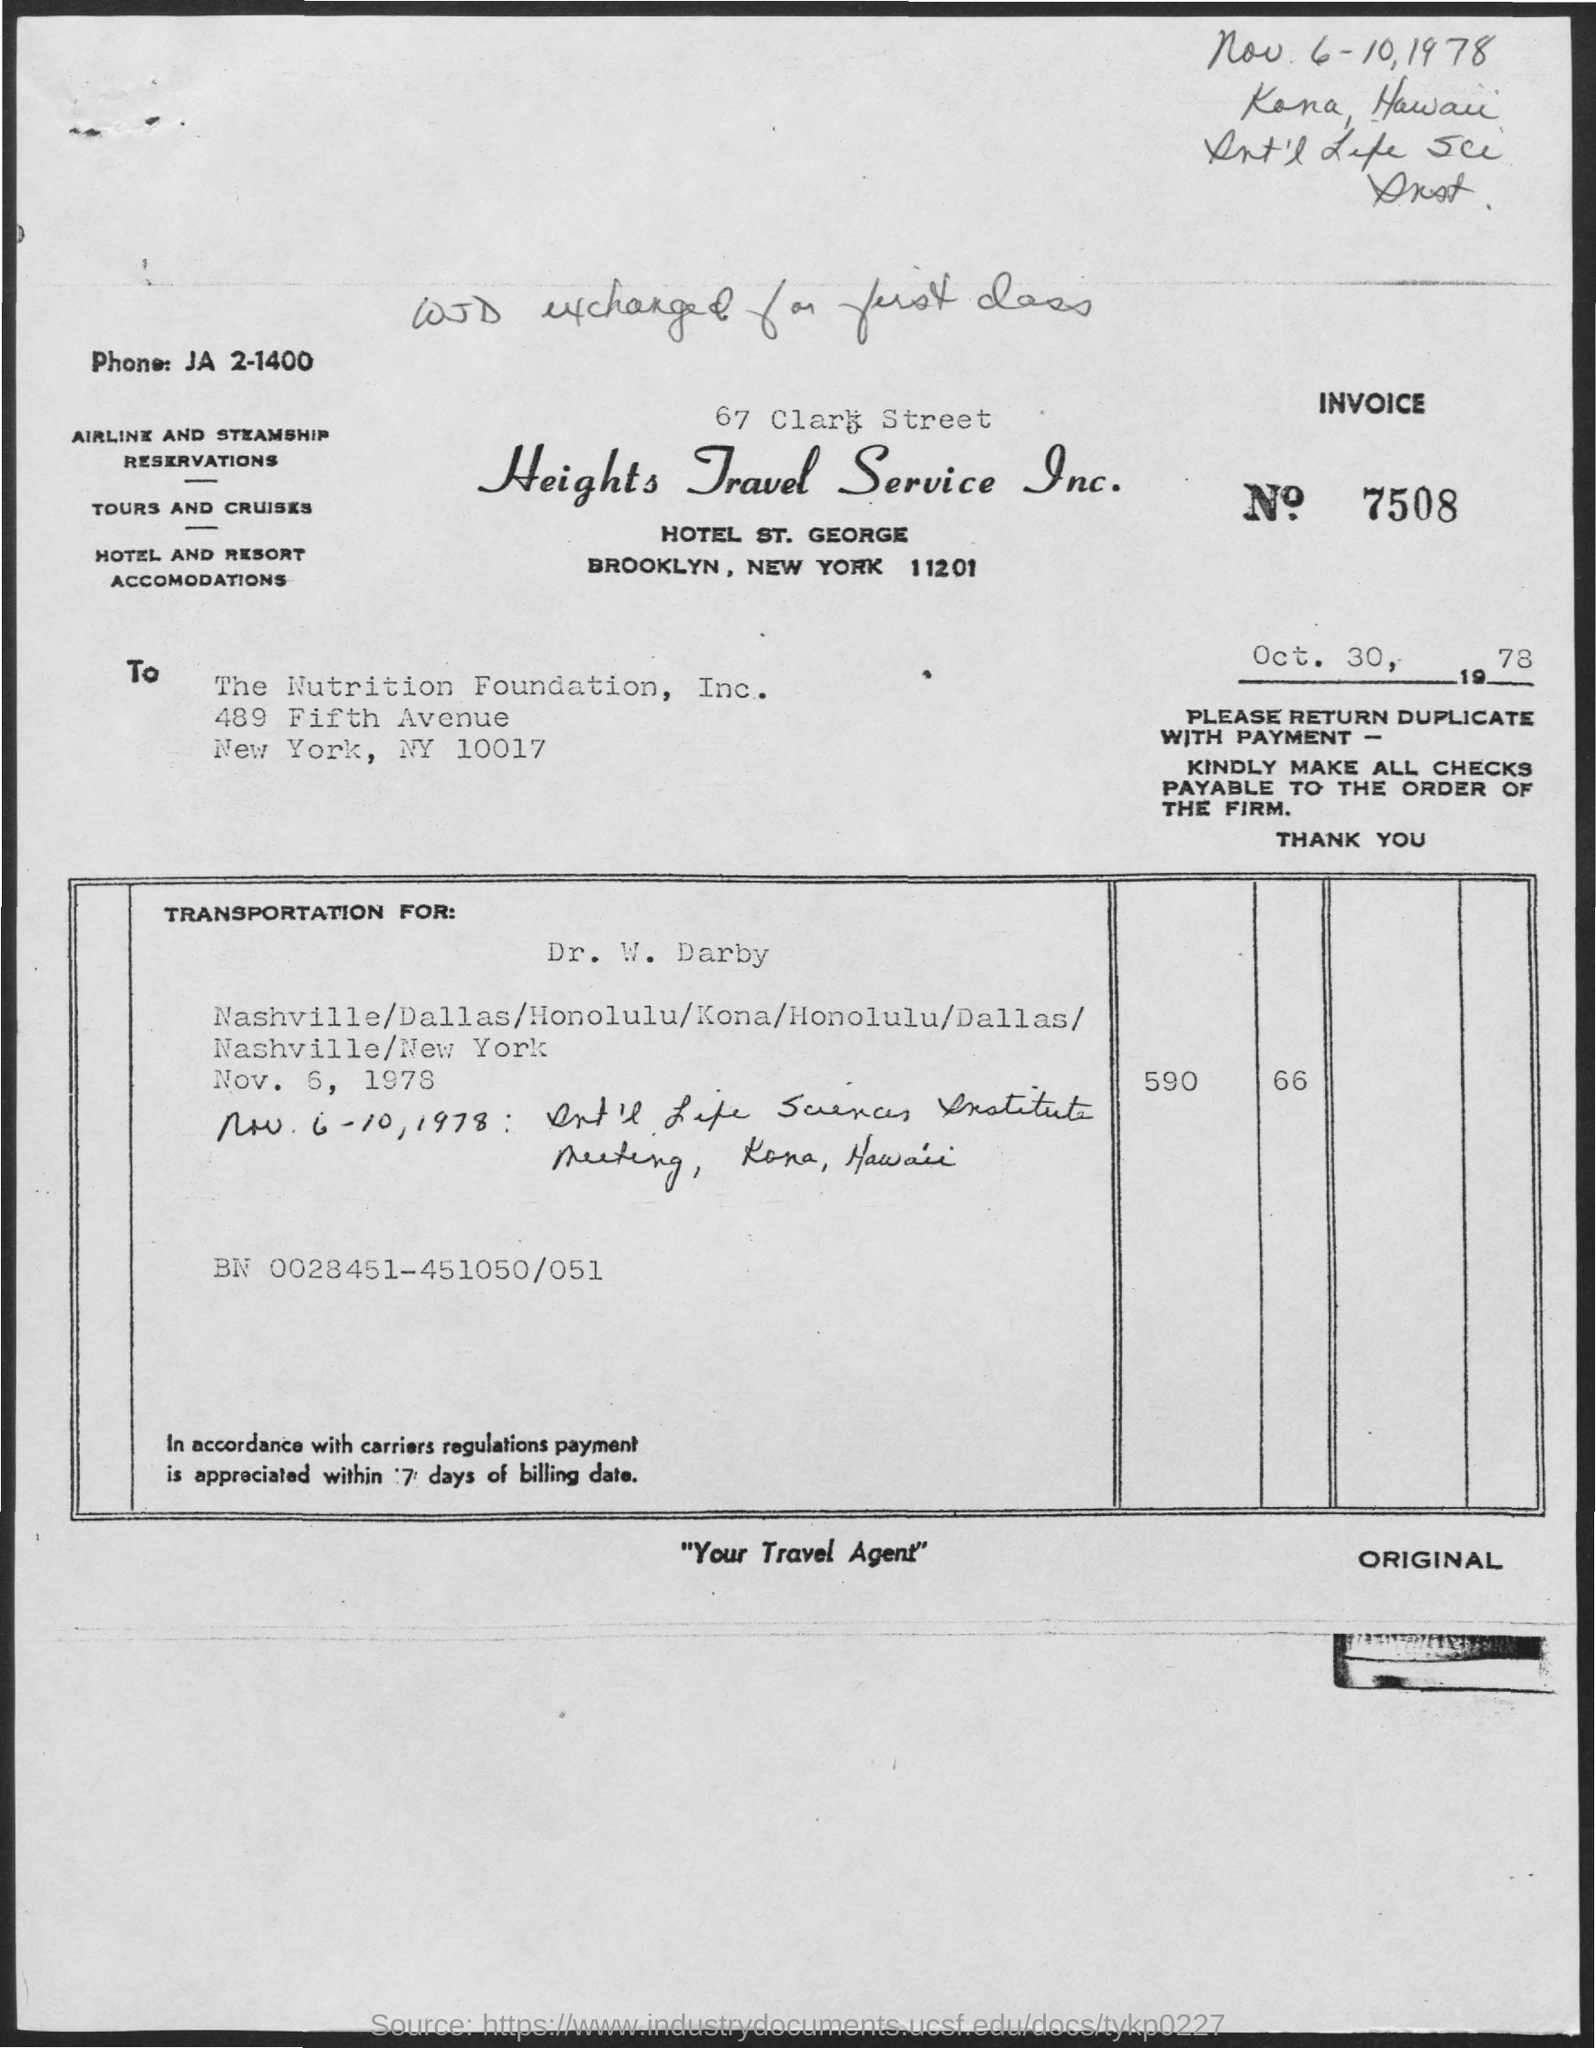What is the invoice no. mentioned in the given form ?
Offer a very short reply. 7508. What is the phone no. mentioned in the given page ?
Your answer should be compact. JA 2-1400. To whom this letter was written ?
Give a very brief answer. The Nutrition Foundation, Inc. 